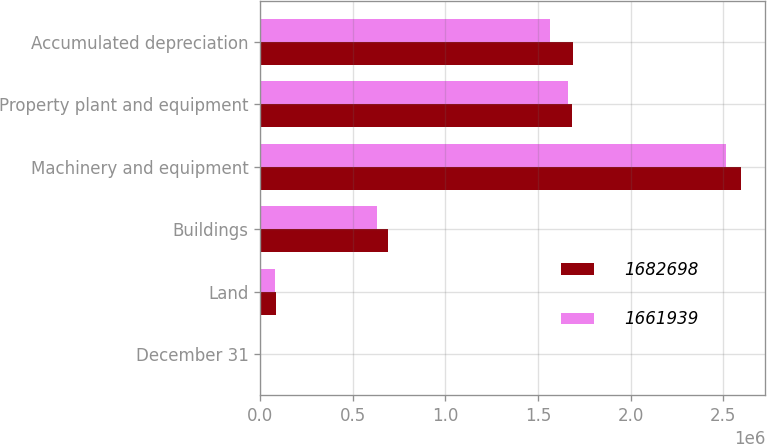Convert chart. <chart><loc_0><loc_0><loc_500><loc_500><stacked_bar_chart><ecel><fcel>December 31<fcel>Land<fcel>Buildings<fcel>Machinery and equipment<fcel>Property plant and equipment<fcel>Accumulated depreciation<nl><fcel>1.6827e+06<fcel>2004<fcel>84563<fcel>688642<fcel>2.596e+06<fcel>1.6827e+06<fcel>1.6865e+06<nl><fcel>1.66194e+06<fcel>2003<fcel>78744<fcel>633362<fcel>2.51492e+06<fcel>1.66194e+06<fcel>1.56508e+06<nl></chart> 